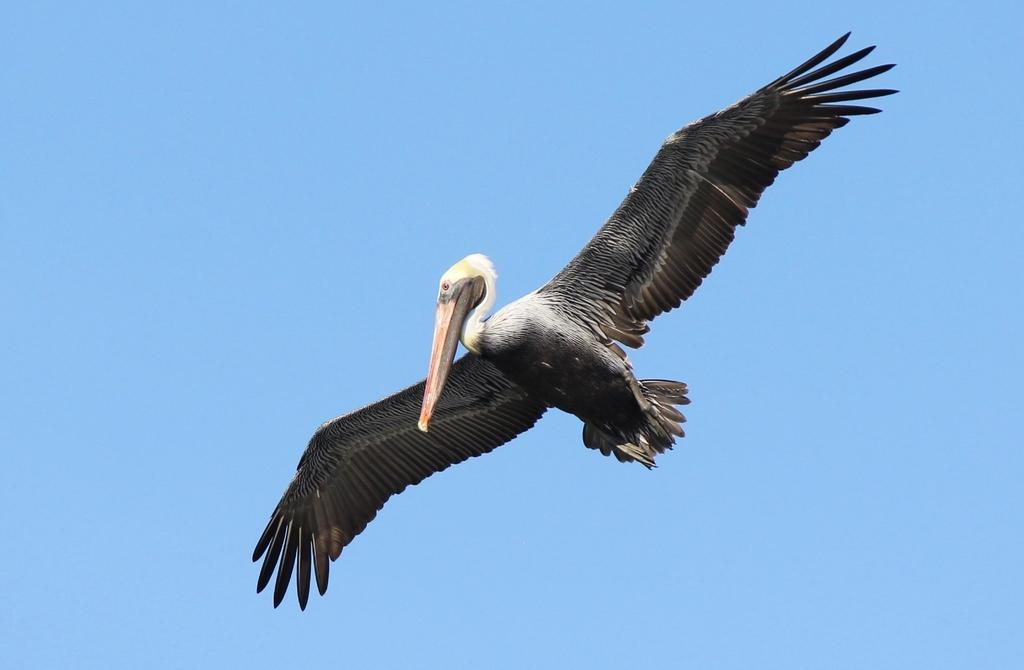Could you give a brief overview of what you see in this image? In the image there is a bird flying in the air and above its sky. 